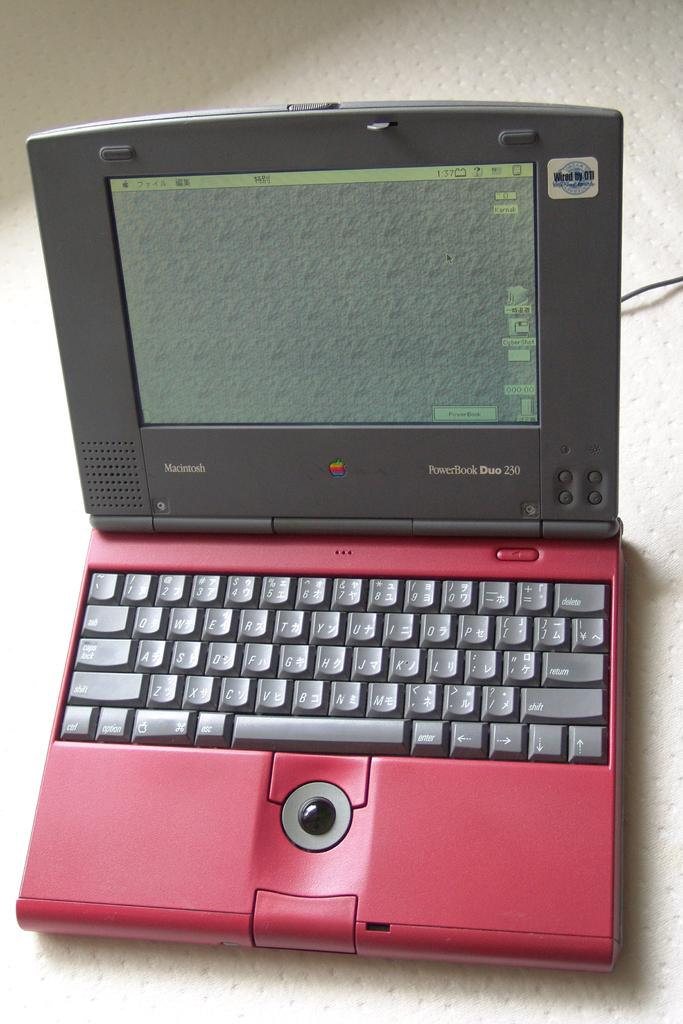<image>
Share a concise interpretation of the image provided. A red and black Powerbook Duo 230 open on a white base 